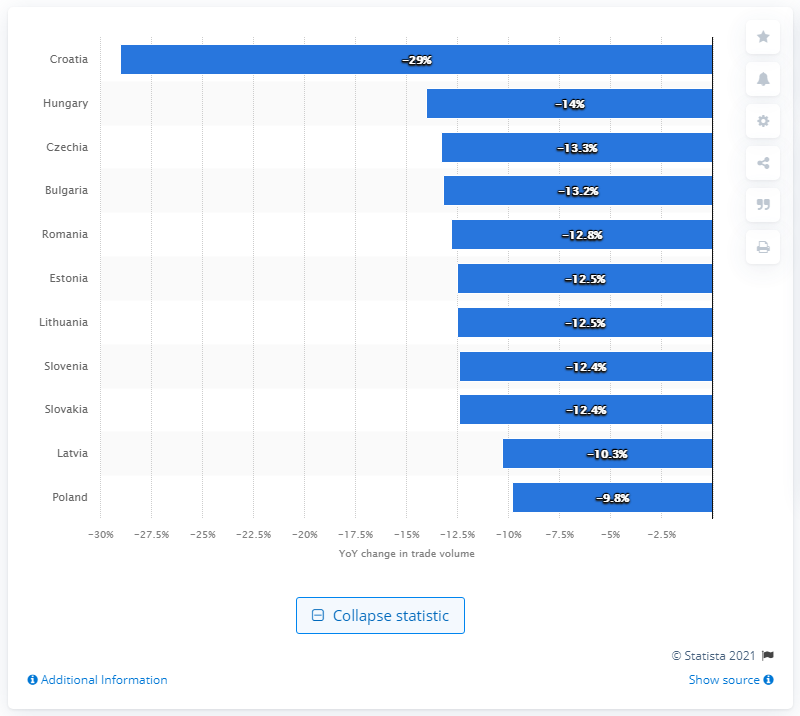Specify some key components in this picture. Poland is the only country in Central and Eastern Europe where the rate of decline in exports is expected to be single-digit, making it an attractive destination for investment and economic growth. Croatia, a country heavily dependent on the tourism sector, relies heavily on the income generated by visitors to its shores. 